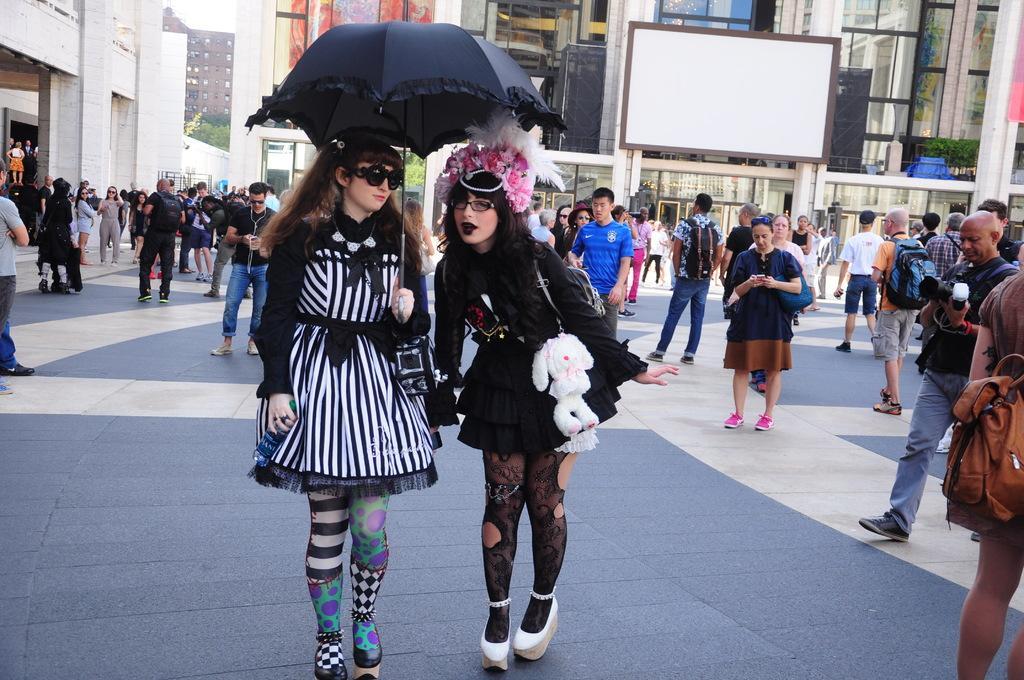Can you describe this image briefly? In this image I can see 2 women standing and holding an umbrella. There are other people at the back. There is a white board and buildings at the back. 